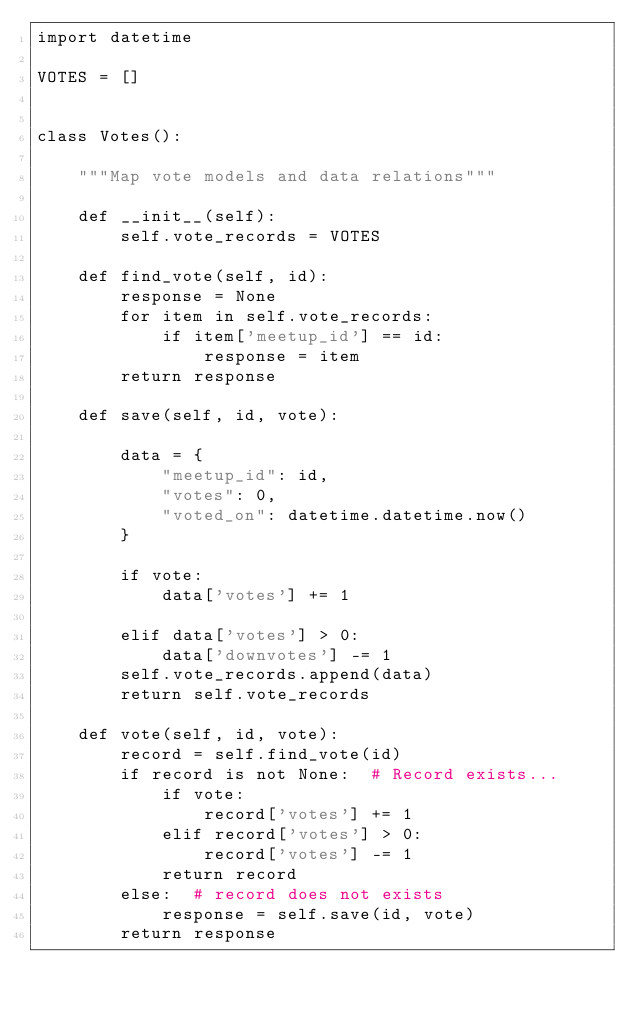Convert code to text. <code><loc_0><loc_0><loc_500><loc_500><_Python_>import datetime

VOTES = []


class Votes():

    """Map vote models and data relations"""

    def __init__(self):
        self.vote_records = VOTES

    def find_vote(self, id):
        response = None
        for item in self.vote_records:
            if item['meetup_id'] == id:
                response = item
        return response

    def save(self, id, vote):

        data = {
            "meetup_id": id,
            "votes": 0,
            "voted_on": datetime.datetime.now()
        }

        if vote:
            data['votes'] += 1

        elif data['votes'] > 0:
            data['downvotes'] -= 1
        self.vote_records.append(data)
        return self.vote_records

    def vote(self, id, vote):
        record = self.find_vote(id)
        if record is not None:  # Record exists...
            if vote:
                record['votes'] += 1
            elif record['votes'] > 0:
                record['votes'] -= 1
            return record
        else:  # record does not exists
            response = self.save(id, vote)
        return response
</code> 